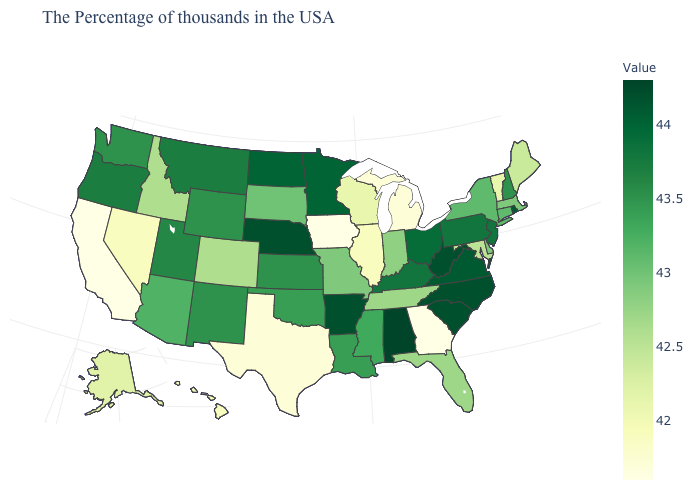Among the states that border Idaho , does Washington have the highest value?
Short answer required. No. 